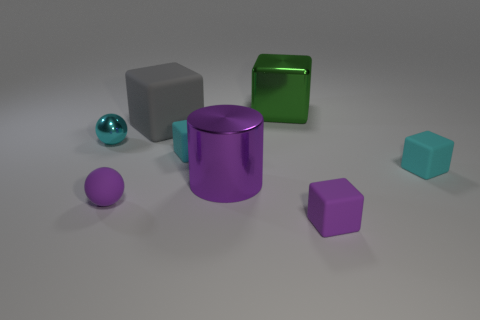What is the shape of the cyan object that is to the right of the purple object in front of the ball in front of the cylinder?
Your answer should be very brief. Cube. What size is the purple rubber sphere?
Give a very brief answer. Small. Is there a tiny cyan block that has the same material as the large purple cylinder?
Give a very brief answer. No. There is a purple object that is the same shape as the cyan metallic thing; what size is it?
Provide a short and direct response. Small. Are there an equal number of tiny rubber spheres that are behind the big gray block and big red rubber spheres?
Offer a terse response. Yes. Do the tiny purple matte object to the left of the large gray thing and the cyan metallic object have the same shape?
Give a very brief answer. Yes. There is a small metal thing; what shape is it?
Offer a terse response. Sphere. What material is the thing that is behind the matte cube behind the object on the left side of the purple ball made of?
Offer a terse response. Metal. There is a small block that is the same color as the cylinder; what material is it?
Your answer should be very brief. Rubber. What number of things are either big gray metallic balls or metal objects?
Your response must be concise. 3. 